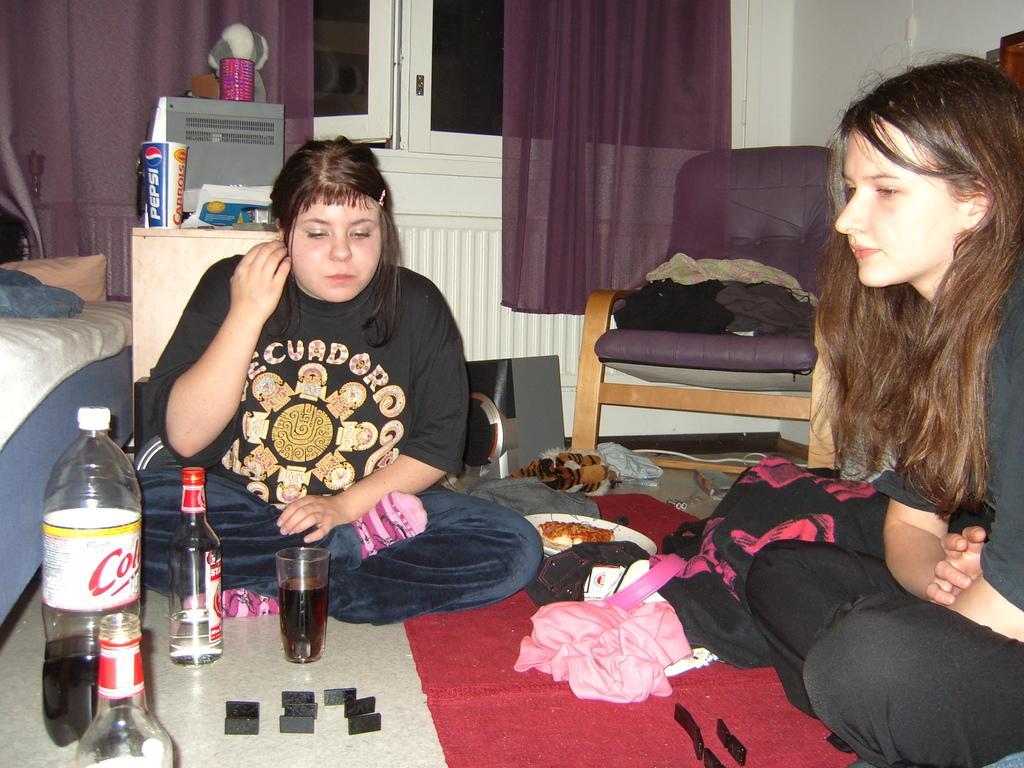Please provide a concise description of this image. In the picture we can see two women wearing black color dress sitting on floor, there are some bottles, glasses, plates on the floor and in the background there is chair, bed, cupboard, there is a window, curtain. 